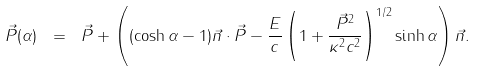Convert formula to latex. <formula><loc_0><loc_0><loc_500><loc_500>\vec { P } ( \alpha ) \ = \ \vec { P } + \left ( ( \cosh \alpha - 1 ) \vec { n } \cdot \vec { P } - \frac { E } { c } \left ( 1 + \frac { \vec { P } ^ { 2 } } { \kappa ^ { 2 } c ^ { 2 } } \right ) ^ { 1 / 2 } \sinh \alpha \right ) \vec { n } .</formula> 